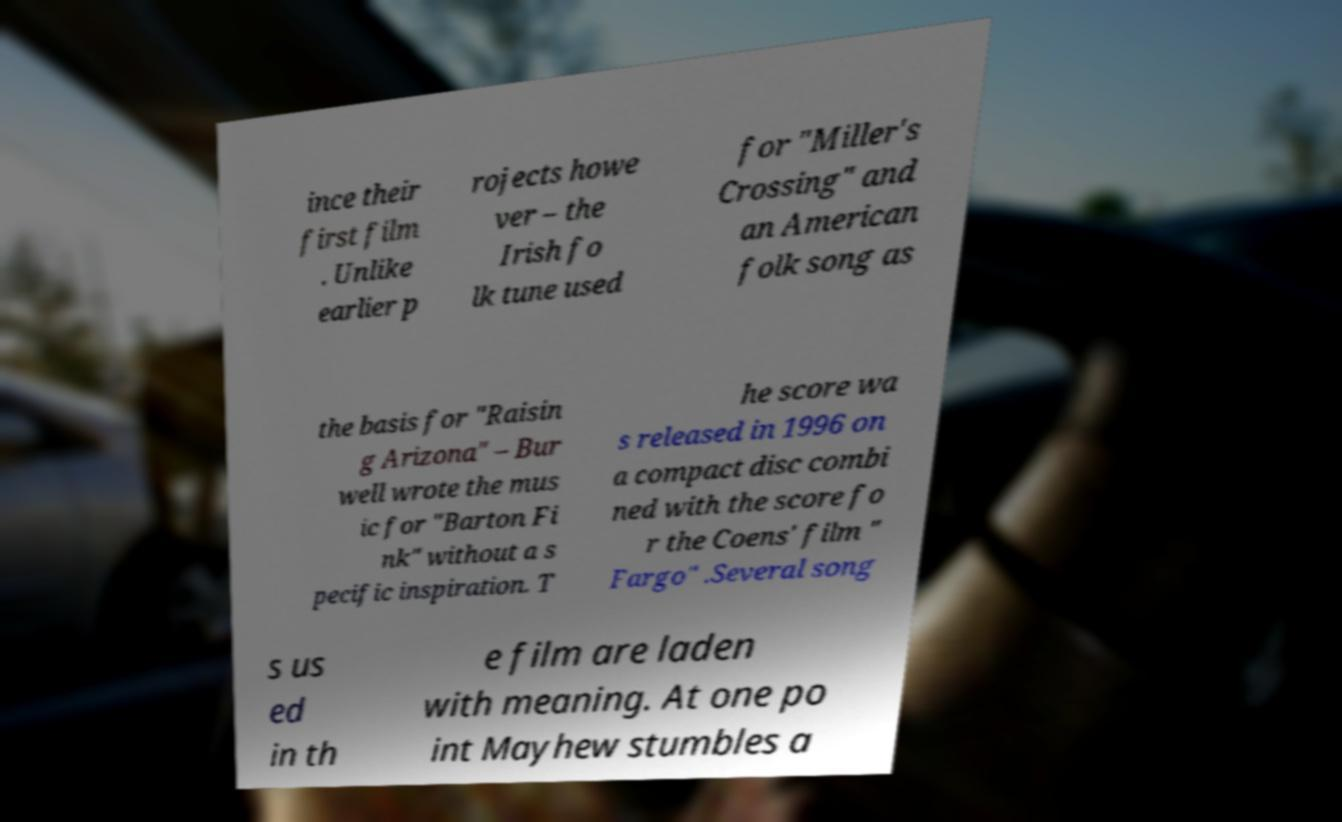There's text embedded in this image that I need extracted. Can you transcribe it verbatim? ince their first film . Unlike earlier p rojects howe ver – the Irish fo lk tune used for "Miller's Crossing" and an American folk song as the basis for "Raisin g Arizona" – Bur well wrote the mus ic for "Barton Fi nk" without a s pecific inspiration. T he score wa s released in 1996 on a compact disc combi ned with the score fo r the Coens' film " Fargo" .Several song s us ed in th e film are laden with meaning. At one po int Mayhew stumbles a 